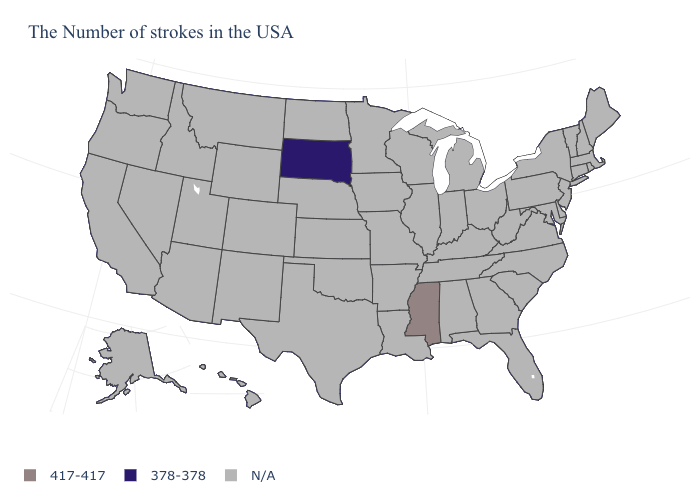Name the states that have a value in the range 378-378?
Write a very short answer. South Dakota. What is the value of Florida?
Answer briefly. N/A. Name the states that have a value in the range N/A?
Short answer required. Maine, Massachusetts, Rhode Island, New Hampshire, Vermont, Connecticut, New York, New Jersey, Delaware, Maryland, Pennsylvania, Virginia, North Carolina, South Carolina, West Virginia, Ohio, Florida, Georgia, Michigan, Kentucky, Indiana, Alabama, Tennessee, Wisconsin, Illinois, Louisiana, Missouri, Arkansas, Minnesota, Iowa, Kansas, Nebraska, Oklahoma, Texas, North Dakota, Wyoming, Colorado, New Mexico, Utah, Montana, Arizona, Idaho, Nevada, California, Washington, Oregon, Alaska, Hawaii. What is the value of South Carolina?
Short answer required. N/A. How many symbols are there in the legend?
Answer briefly. 3. Name the states that have a value in the range 417-417?
Keep it brief. Mississippi. What is the highest value in states that border Iowa?
Keep it brief. 378-378. Name the states that have a value in the range 378-378?
Keep it brief. South Dakota. What is the highest value in the USA?
Answer briefly. 417-417. What is the value of Oregon?
Answer briefly. N/A. What is the lowest value in the USA?
Give a very brief answer. 378-378. 